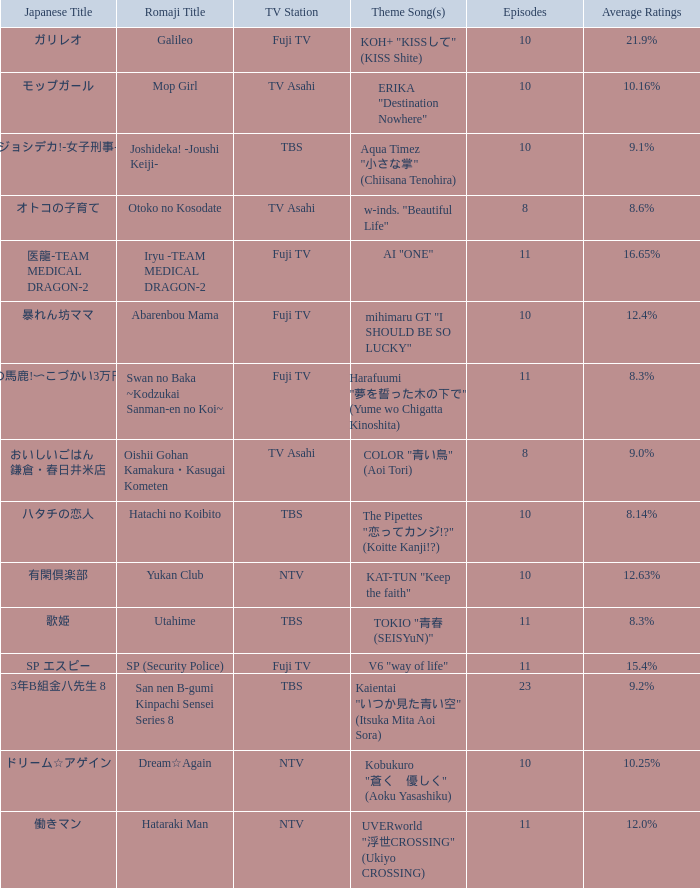What is the Theme Song of 働きマン? UVERworld "浮世CROSSING" (Ukiyo CROSSING). 